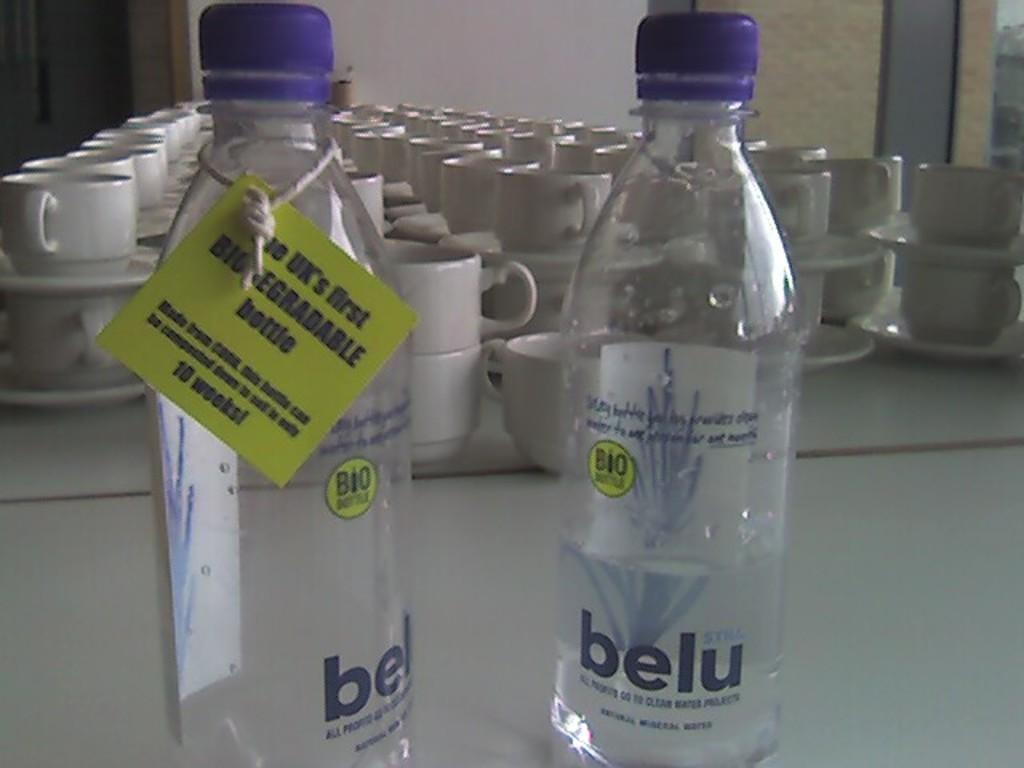<image>
Summarize the visual content of the image. Belu is the brand printed on the label of these water bottles. 